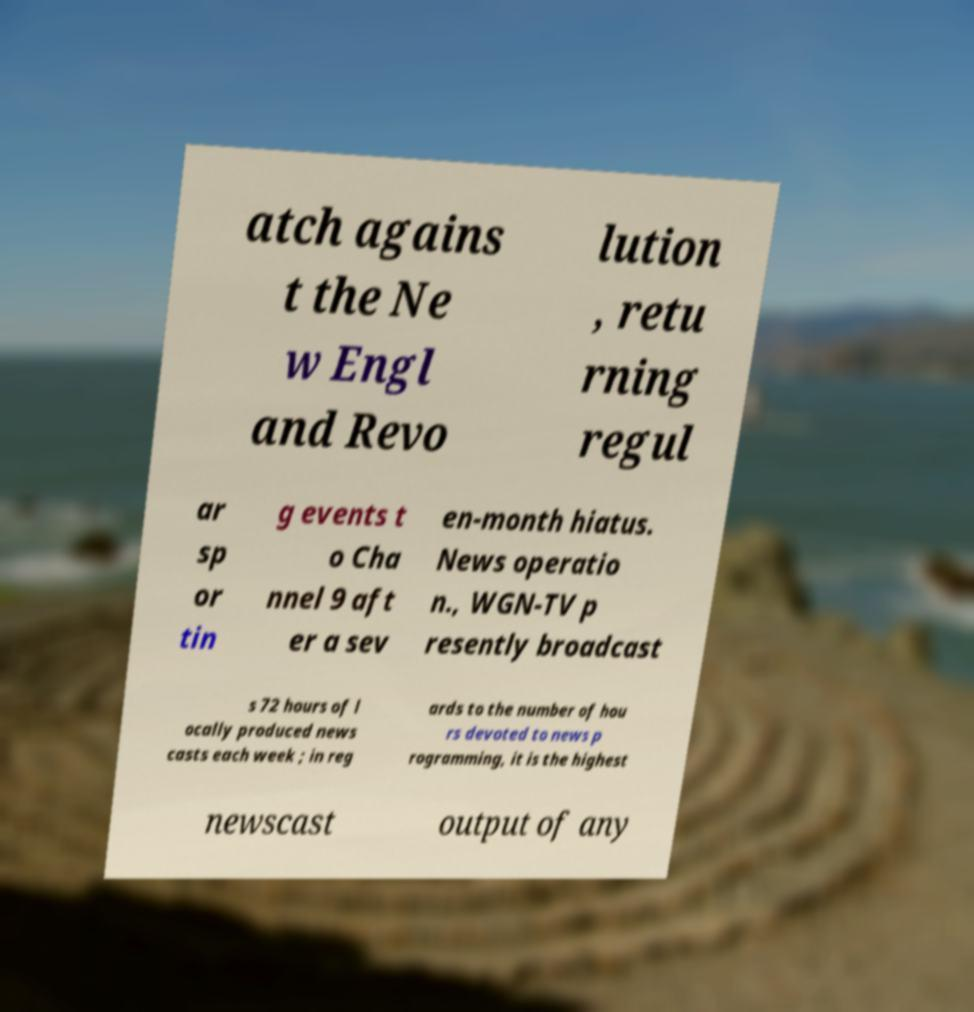Could you extract and type out the text from this image? atch agains t the Ne w Engl and Revo lution , retu rning regul ar sp or tin g events t o Cha nnel 9 aft er a sev en-month hiatus. News operatio n., WGN-TV p resently broadcast s 72 hours of l ocally produced news casts each week ; in reg ards to the number of hou rs devoted to news p rogramming, it is the highest newscast output of any 